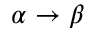<formula> <loc_0><loc_0><loc_500><loc_500>\alpha \rightarrow \beta</formula> 